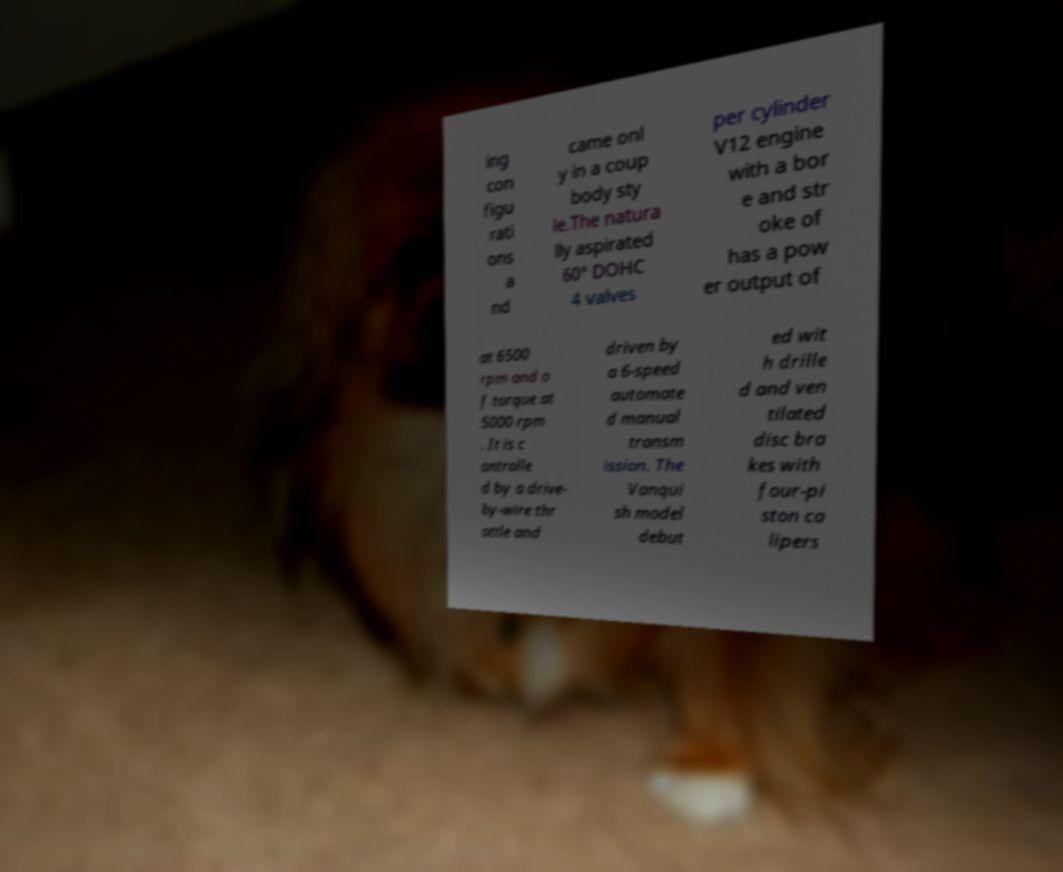There's text embedded in this image that I need extracted. Can you transcribe it verbatim? ing con figu rati ons a nd came onl y in a coup body sty le.The natura lly aspirated 60° DOHC 4 valves per cylinder V12 engine with a bor e and str oke of has a pow er output of at 6500 rpm and o f torque at 5000 rpm . It is c ontrolle d by a drive- by-wire thr ottle and driven by a 6-speed automate d manual transm ission. The Vanqui sh model debut ed wit h drille d and ven tilated disc bra kes with four-pi ston ca lipers 